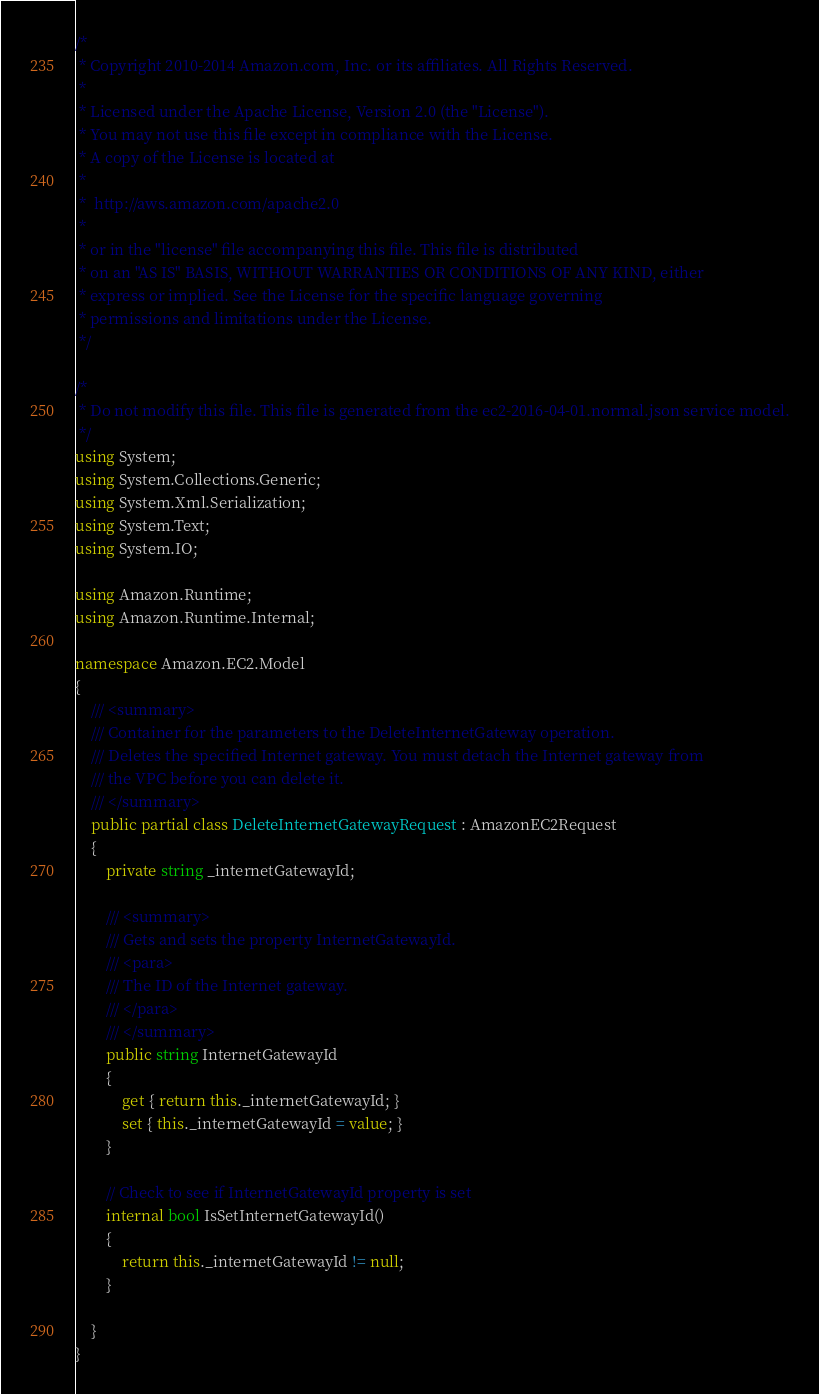<code> <loc_0><loc_0><loc_500><loc_500><_C#_>/*
 * Copyright 2010-2014 Amazon.com, Inc. or its affiliates. All Rights Reserved.
 * 
 * Licensed under the Apache License, Version 2.0 (the "License").
 * You may not use this file except in compliance with the License.
 * A copy of the License is located at
 * 
 *  http://aws.amazon.com/apache2.0
 * 
 * or in the "license" file accompanying this file. This file is distributed
 * on an "AS IS" BASIS, WITHOUT WARRANTIES OR CONDITIONS OF ANY KIND, either
 * express or implied. See the License for the specific language governing
 * permissions and limitations under the License.
 */

/*
 * Do not modify this file. This file is generated from the ec2-2016-04-01.normal.json service model.
 */
using System;
using System.Collections.Generic;
using System.Xml.Serialization;
using System.Text;
using System.IO;

using Amazon.Runtime;
using Amazon.Runtime.Internal;

namespace Amazon.EC2.Model
{
    /// <summary>
    /// Container for the parameters to the DeleteInternetGateway operation.
    /// Deletes the specified Internet gateway. You must detach the Internet gateway from
    /// the VPC before you can delete it.
    /// </summary>
    public partial class DeleteInternetGatewayRequest : AmazonEC2Request
    {
        private string _internetGatewayId;

        /// <summary>
        /// Gets and sets the property InternetGatewayId. 
        /// <para>
        /// The ID of the Internet gateway.
        /// </para>
        /// </summary>
        public string InternetGatewayId
        {
            get { return this._internetGatewayId; }
            set { this._internetGatewayId = value; }
        }

        // Check to see if InternetGatewayId property is set
        internal bool IsSetInternetGatewayId()
        {
            return this._internetGatewayId != null;
        }

    }
}</code> 